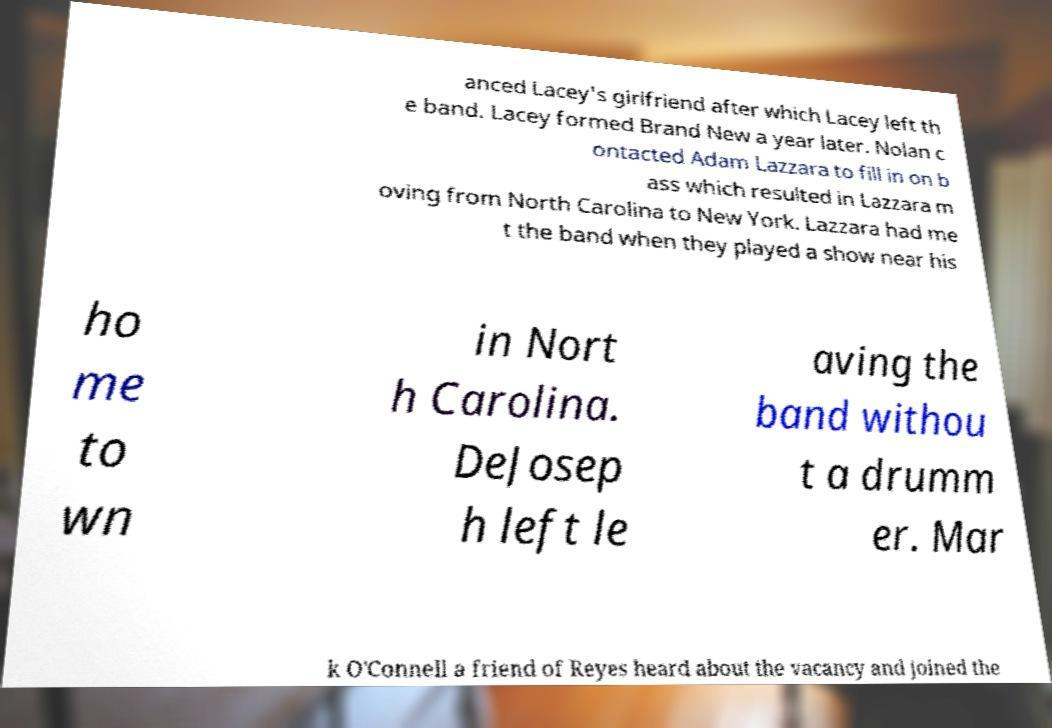Can you read and provide the text displayed in the image?This photo seems to have some interesting text. Can you extract and type it out for me? anced Lacey's girlfriend after which Lacey left th e band. Lacey formed Brand New a year later. Nolan c ontacted Adam Lazzara to fill in on b ass which resulted in Lazzara m oving from North Carolina to New York. Lazzara had me t the band when they played a show near his ho me to wn in Nort h Carolina. DeJosep h left le aving the band withou t a drumm er. Mar k O'Connell a friend of Reyes heard about the vacancy and joined the 